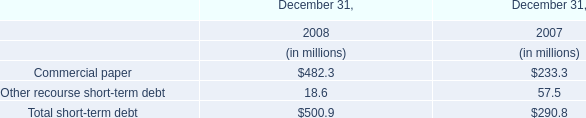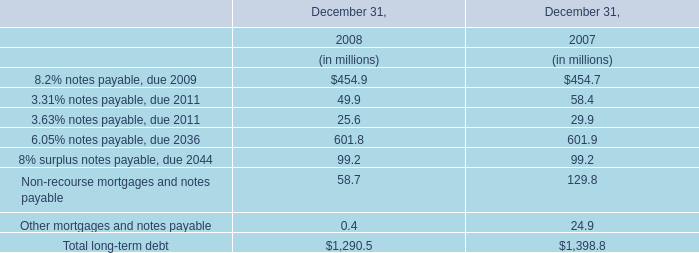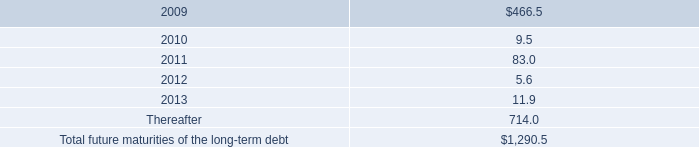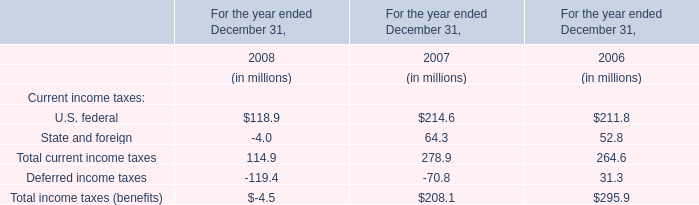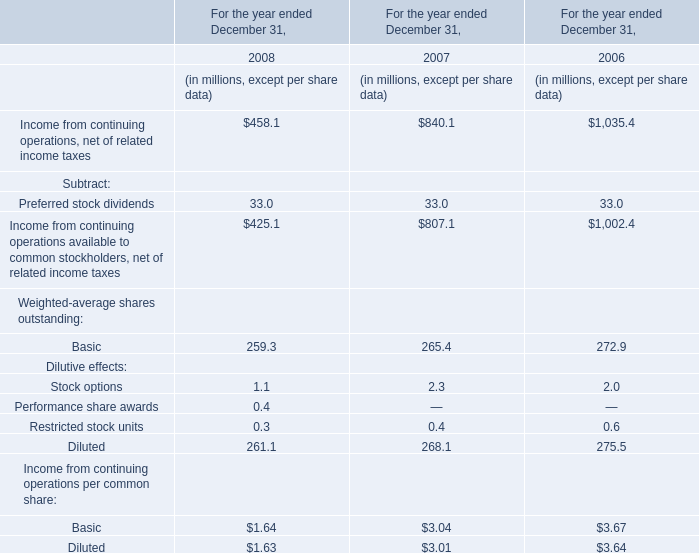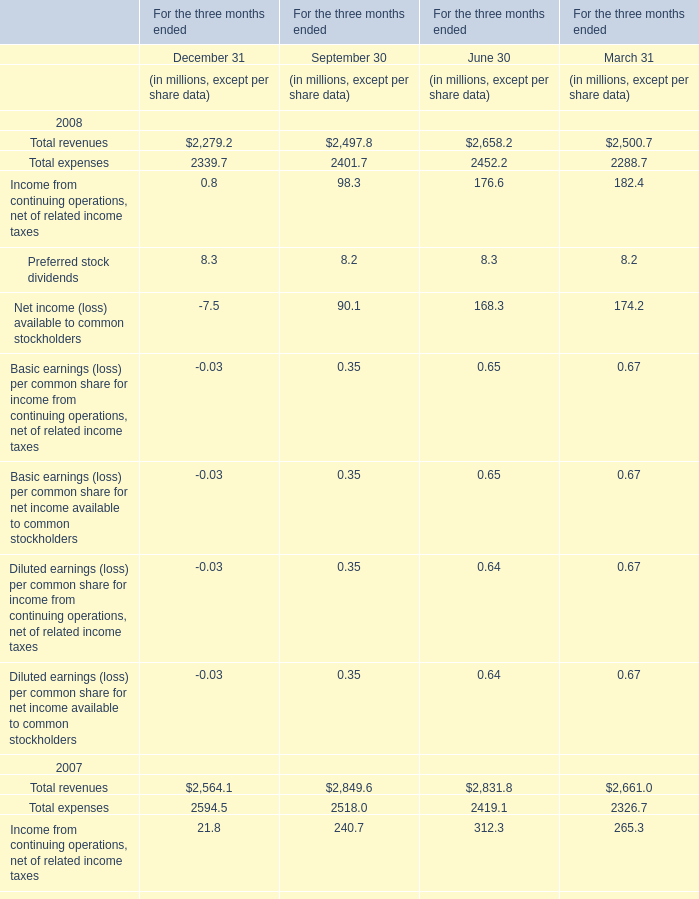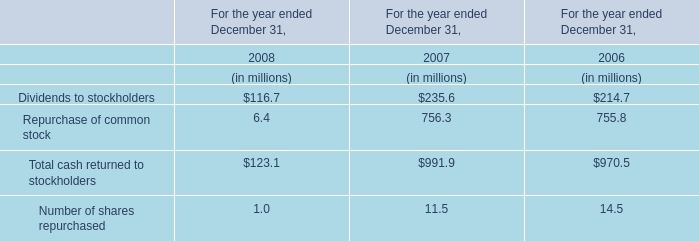Which year is Income from continuing operations, net of related income taxes the highest? 
Answer: 2006. 